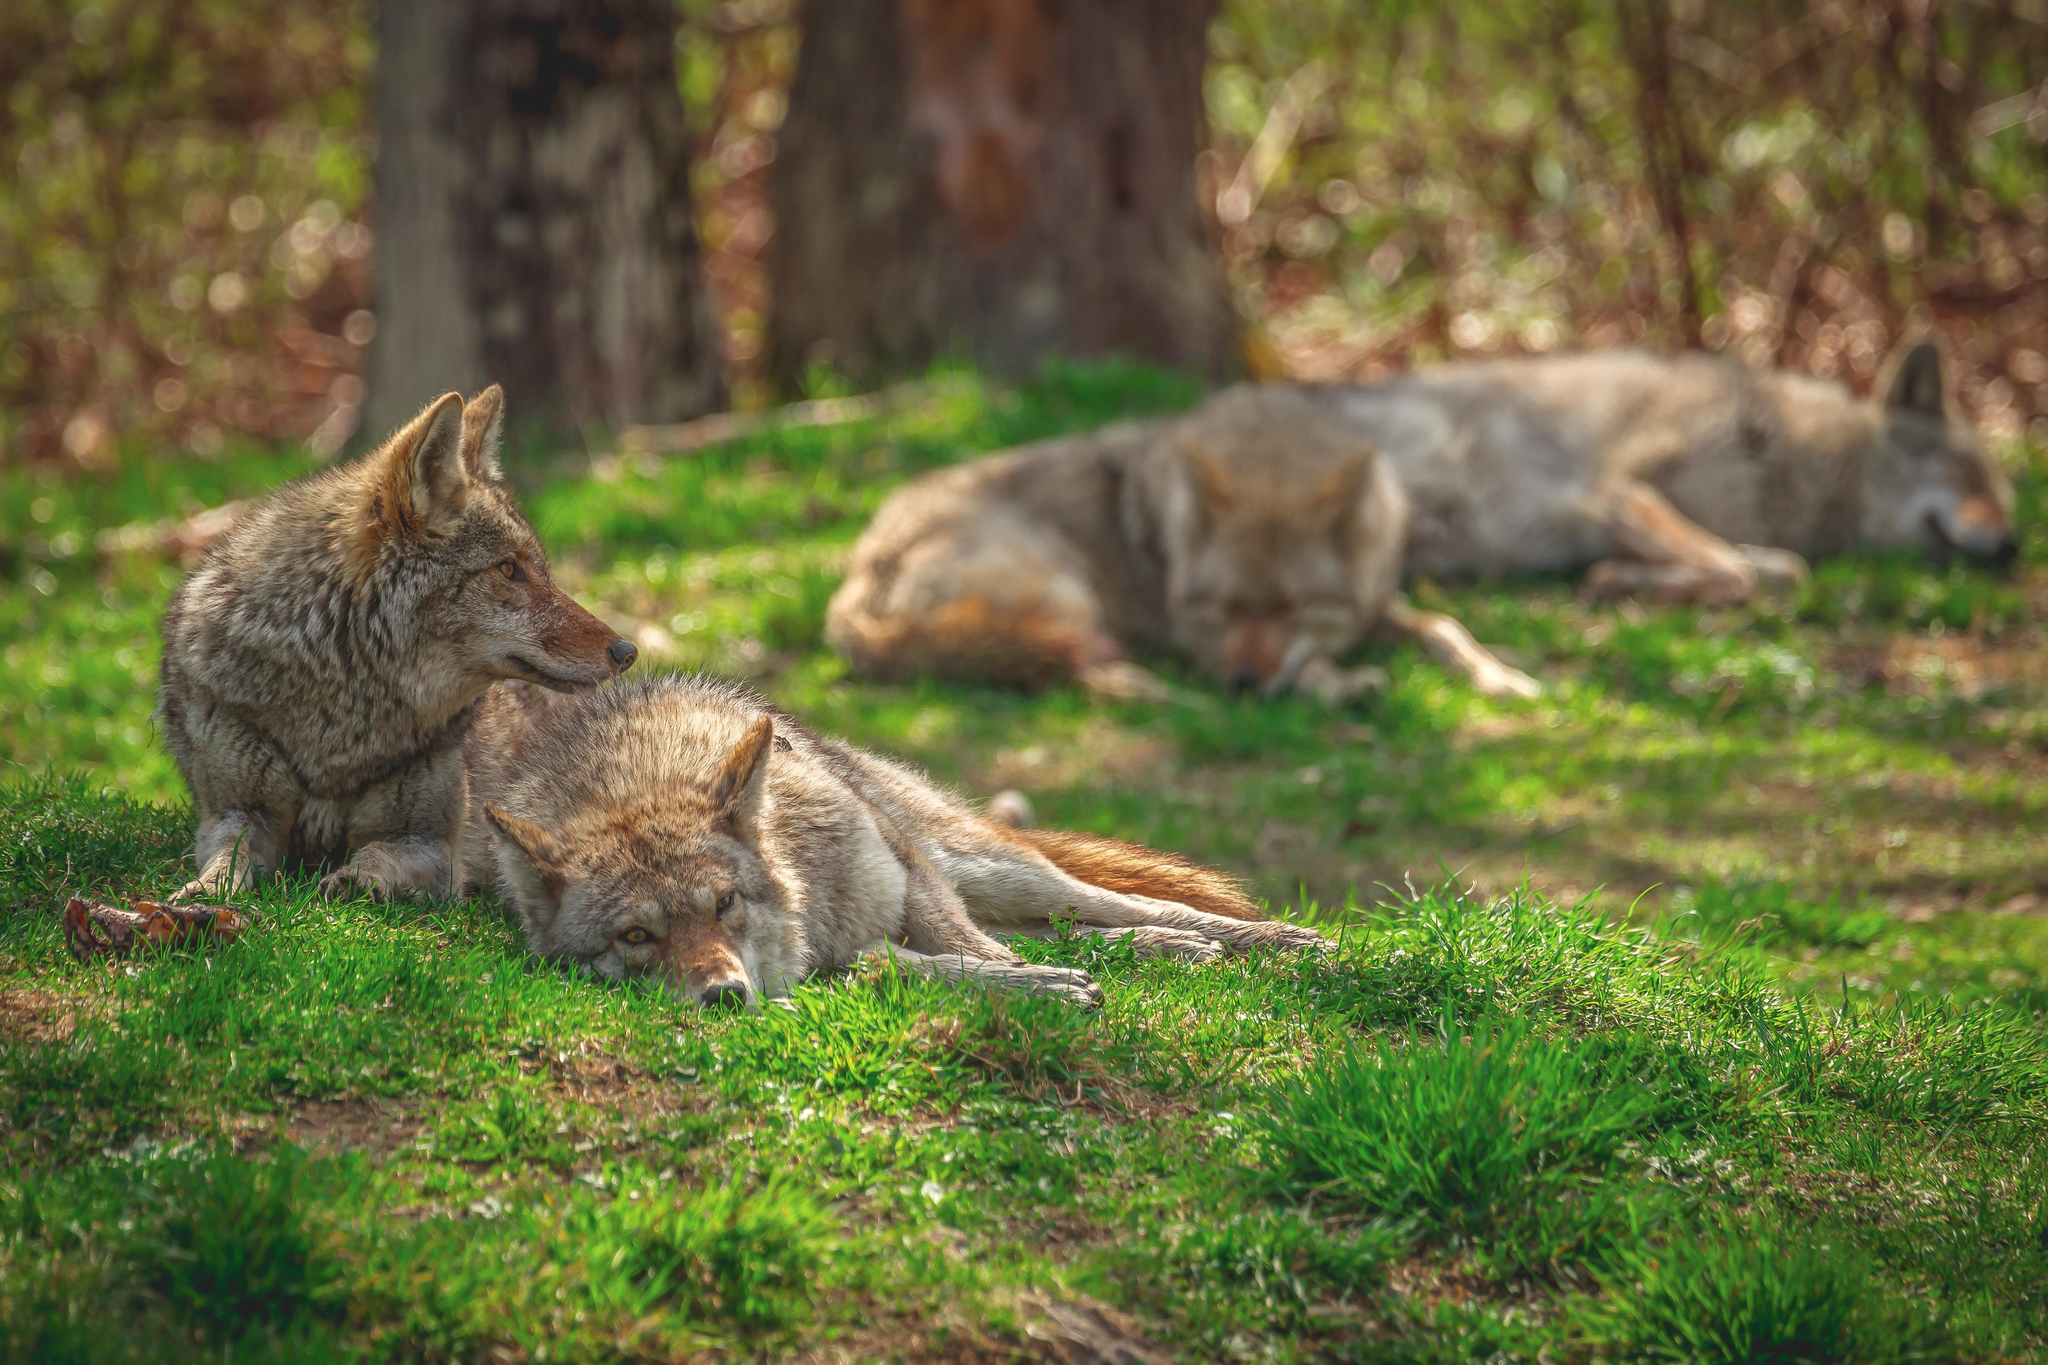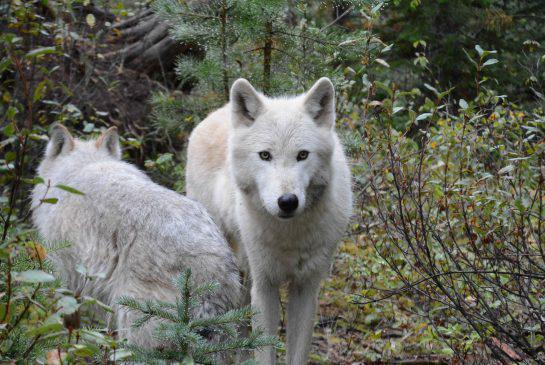The first image is the image on the left, the second image is the image on the right. Examine the images to the left and right. Is the description "There are at least three canines." accurate? Answer yes or no. Yes. The first image is the image on the left, the second image is the image on the right. Given the left and right images, does the statement "At least one of the wild dogs is laying down and none are in snow." hold true? Answer yes or no. Yes. 